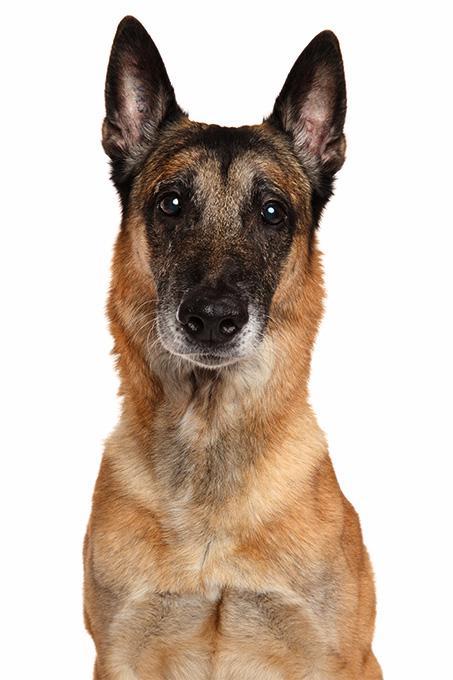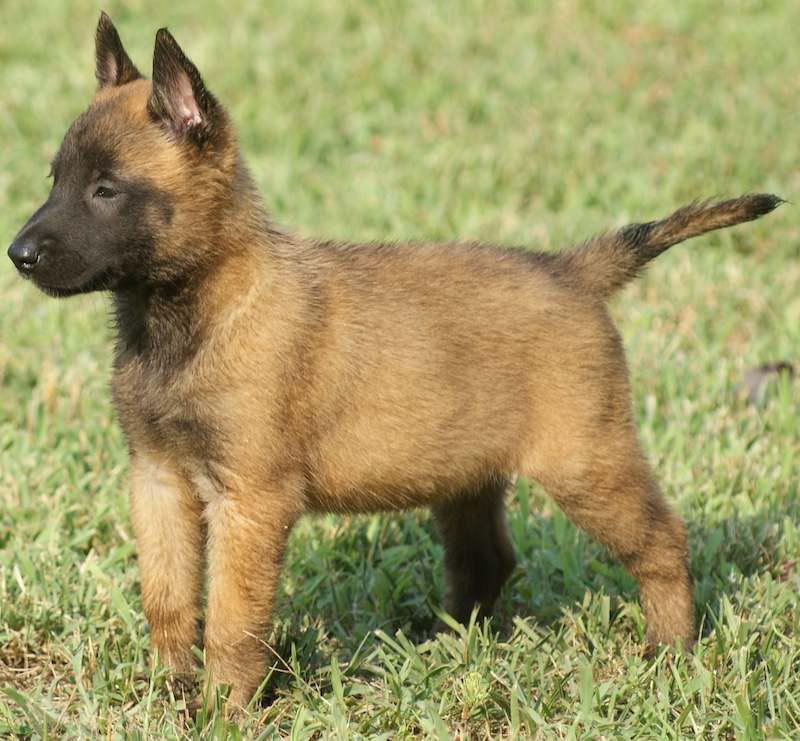The first image is the image on the left, the second image is the image on the right. Evaluate the accuracy of this statement regarding the images: "In at least one image, a dog is gripping a toy in its mouth.". Is it true? Answer yes or no. No. 